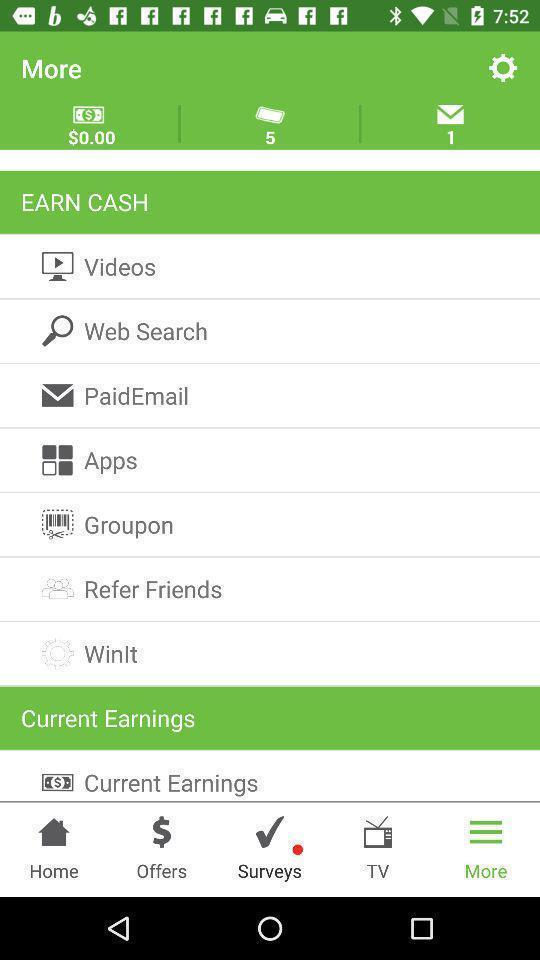Describe the visual elements of this screenshot. List of various options. 